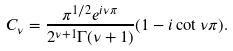<formula> <loc_0><loc_0><loc_500><loc_500>C _ { \nu } = \frac { \pi ^ { 1 / 2 } e ^ { i \nu \pi } } { 2 ^ { \nu + 1 } \Gamma ( \nu + 1 ) } ( 1 - i \cot \nu \pi ) .</formula> 